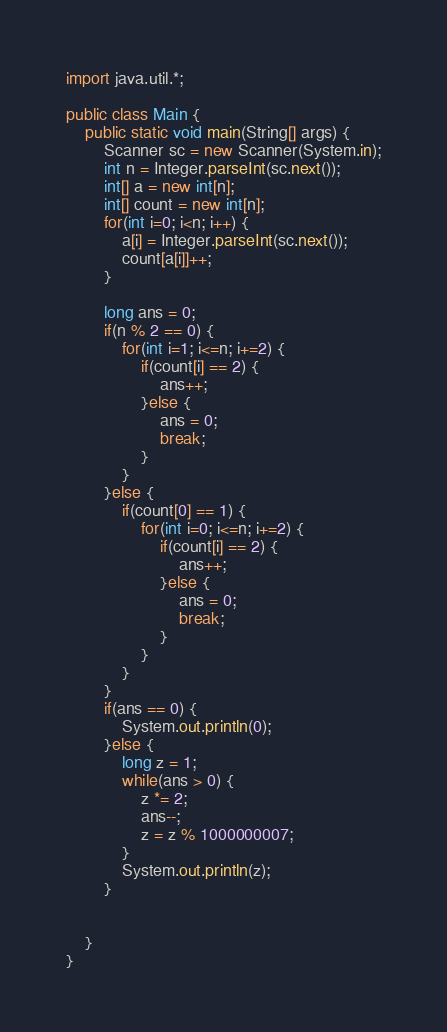Convert code to text. <code><loc_0><loc_0><loc_500><loc_500><_Java_>import java.util.*;

public class Main {
    public static void main(String[] args) {
        Scanner sc = new Scanner(System.in);
        int n = Integer.parseInt(sc.next());
        int[] a = new int[n];
        int[] count = new int[n];
        for(int i=0; i<n; i++) {
            a[i] = Integer.parseInt(sc.next());
            count[a[i]]++;
        }
        
        long ans = 0;
        if(n % 2 == 0) {
            for(int i=1; i<=n; i+=2) {
                if(count[i] == 2) {
                    ans++;
                }else {
                    ans = 0;
                    break;
                }
            }
        }else {
            if(count[0] == 1) {
                for(int i=0; i<=n; i+=2) {
                    if(count[i] == 2) {
                        ans++;
                    }else {
                        ans = 0;
                        break;
                    }
                }
            }
        }
        if(ans == 0) {
            System.out.println(0);
        }else {
            long z = 1;
            while(ans > 0) {
                z *= 2;
                ans--;
                z = z % 1000000007;
            }
            System.out.println(z);
        }

        
    }
}
</code> 